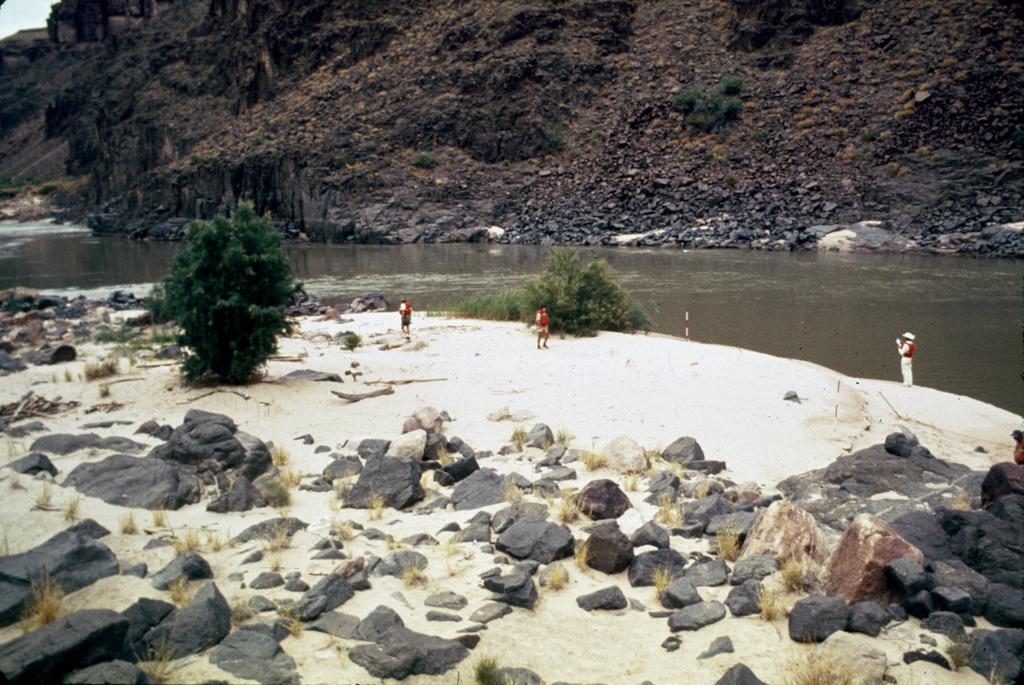Please provide a concise description of this image. In this image, there are a few people. We can see the ground and some stones. We can also see some plants and grass. We can see some water and hills. We can also see the sky. 